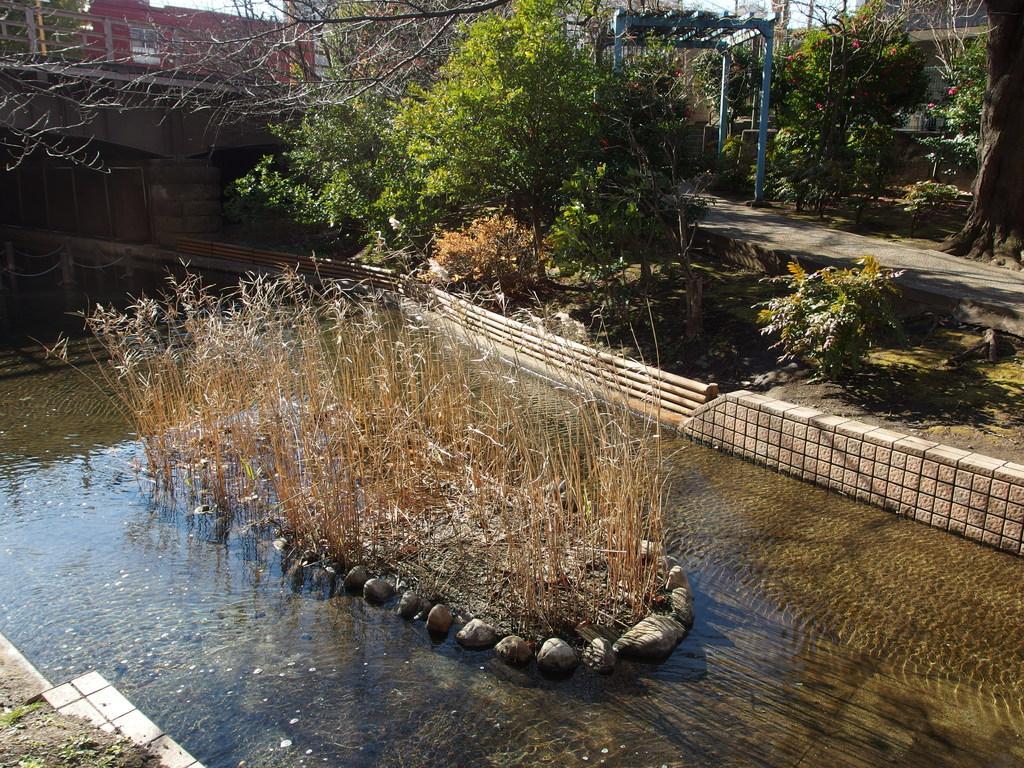Please provide a concise description of this image. This picture is taken from outside of the city. In this image, in the middle, we can see some plants and stones which are placed on the water. On the right side, we can see some trees, plants, flowers, pole. In the left corner, we can see a land with some grass. In the background, we can see a building, trees, plants. At the bottom, we can see some plants and a grass. 